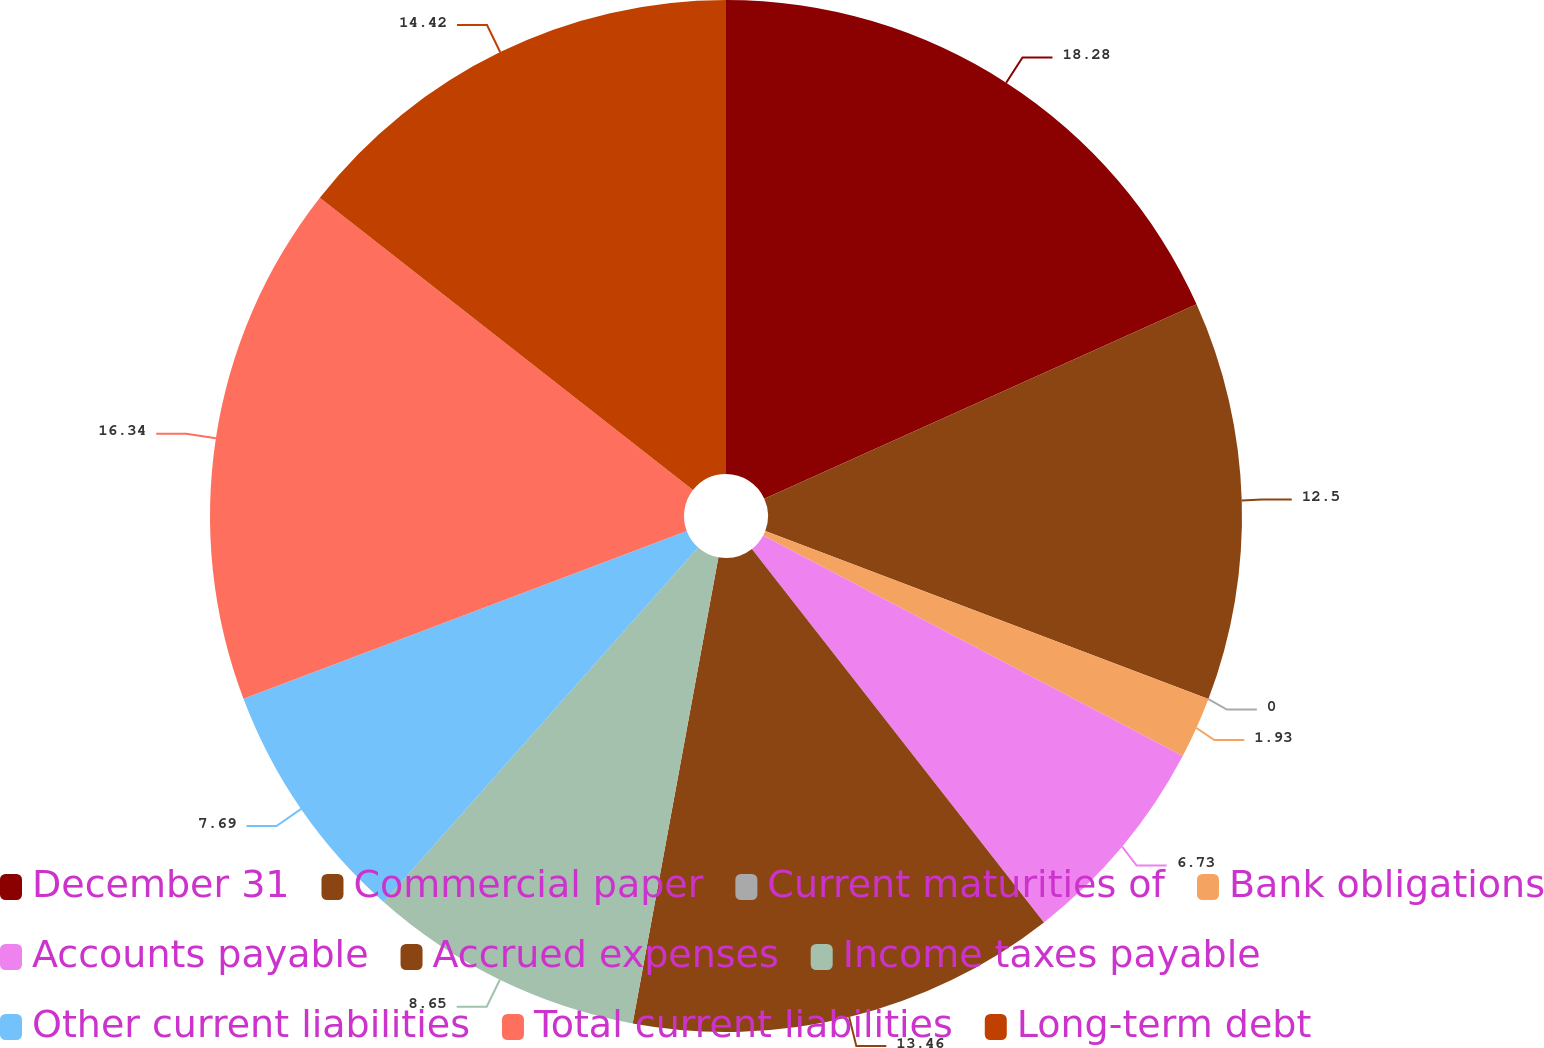Convert chart to OTSL. <chart><loc_0><loc_0><loc_500><loc_500><pie_chart><fcel>December 31<fcel>Commercial paper<fcel>Current maturities of<fcel>Bank obligations<fcel>Accounts payable<fcel>Accrued expenses<fcel>Income taxes payable<fcel>Other current liabilities<fcel>Total current liabilities<fcel>Long-term debt<nl><fcel>18.27%<fcel>12.5%<fcel>0.0%<fcel>1.93%<fcel>6.73%<fcel>13.46%<fcel>8.65%<fcel>7.69%<fcel>16.34%<fcel>14.42%<nl></chart> 